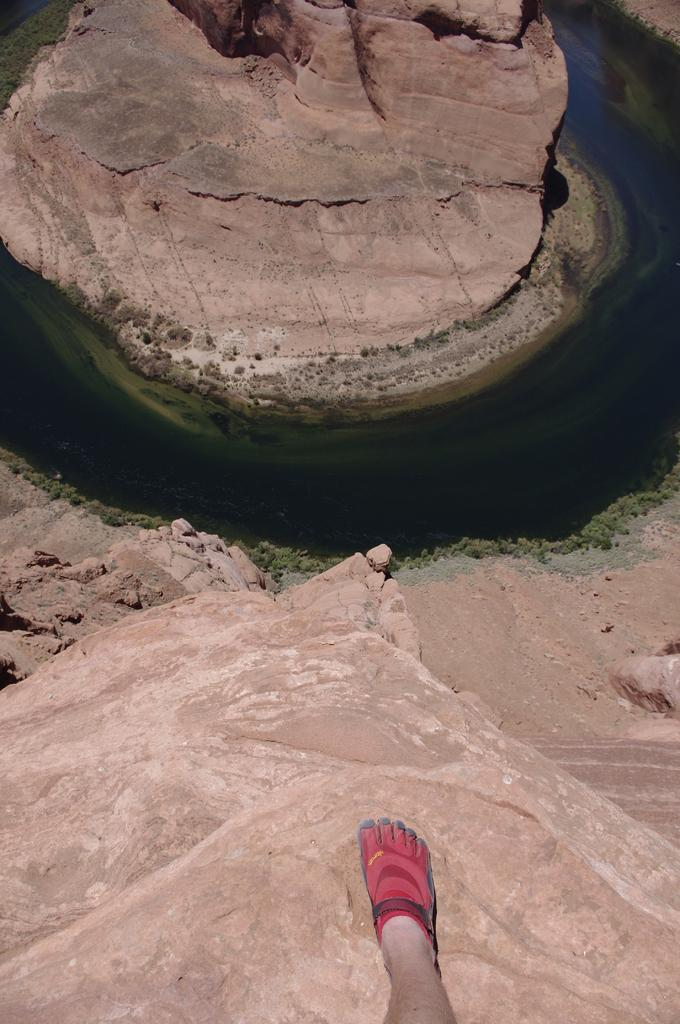What part of a person can be seen in the image? There is a leg of a person in the image. What type of environment is visible in the background of the image? Grass and water are visible in the background of the image. What type of business is being discussed in the image? There is no discussion or business present in the image; it only features a leg of a person and a grassy, watery background. 